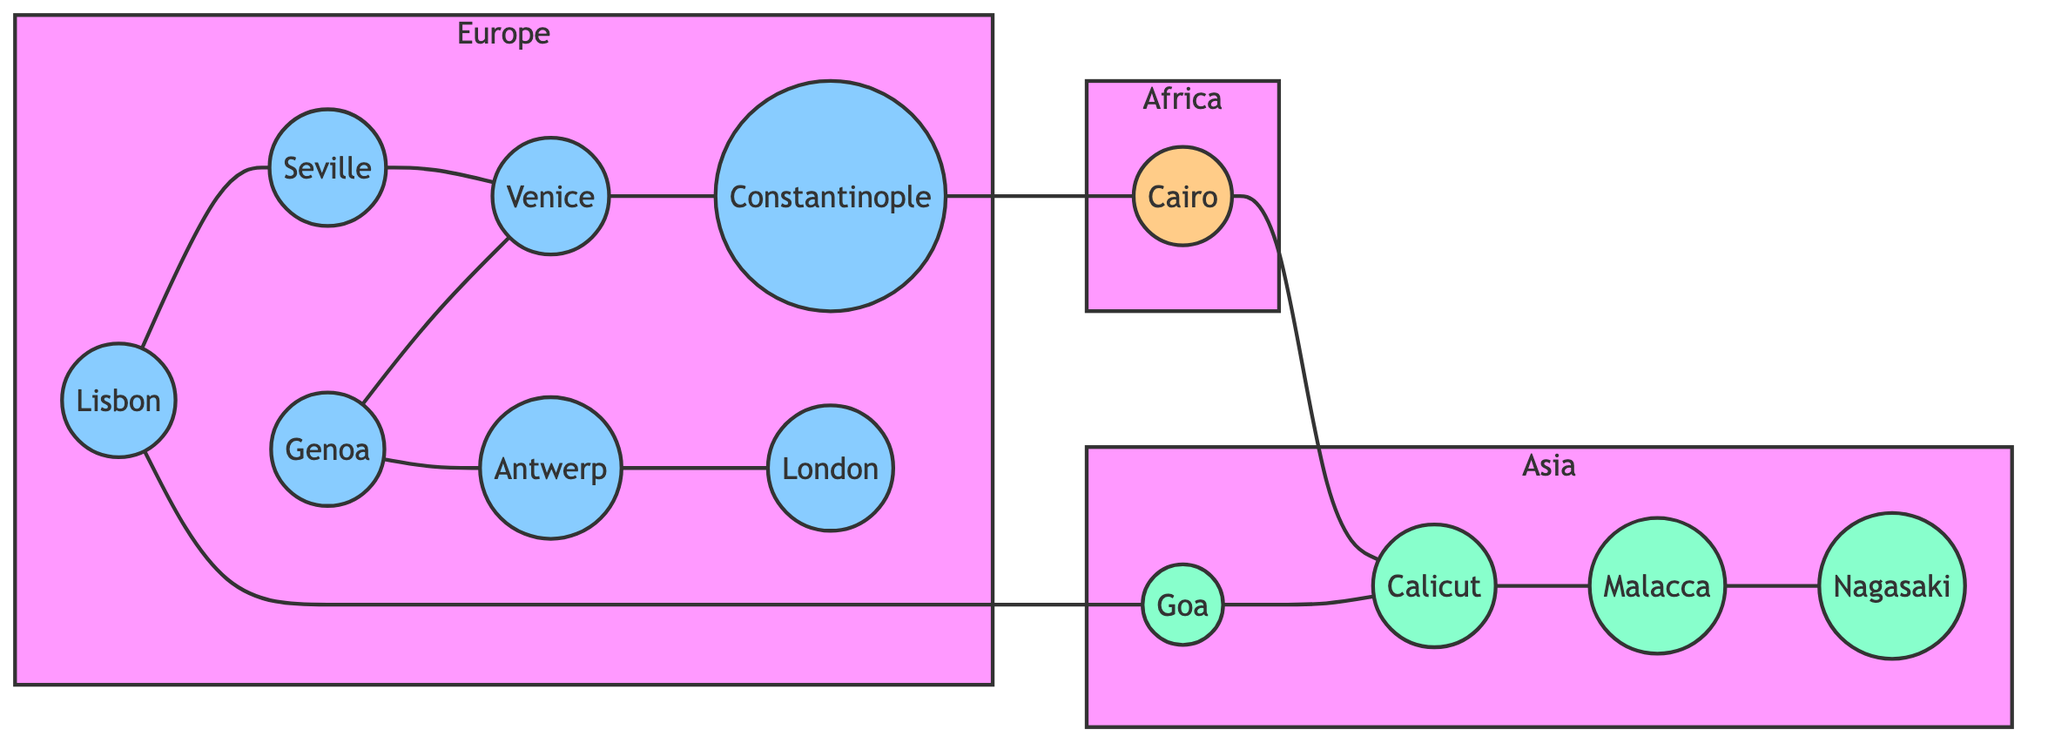What is the total number of nodes in the graph? The graph has nodes representing various trade hubs in the 16th century. Counting each individual node listed in the data gives us a total of 12 nodes.
Answer: 12 Which two cities are directly connected to Lisbon? In the diagram, the edges originating from Lisbon connect it to Seville and Goa. By observing the edges connected to Lisbon, we can identify these two cities.
Answer: Seville, Goa What is the only African city in the graph? The graph depicts various trade hubs from different continents. By examining the nodes, we find that Cairo is the only city placed in the Africa subgraph.
Answer: Cairo Which European city is connected to Antwerp? The connections in the graph show that Antwerp is directly connected to London. By looking at the edge linking these two nodes, we can identify London as the connected city.
Answer: London How many direct connections does Venice have? Reviewing the edges connected to Venice shows that it has two direct connections: one to Seville and another to Constantinople. Thus, the total number of direct connections can be determined as two.
Answer: 2 Which city is the last in the trade route starting from Malacca? Tracing the edges from Malacca leads to Nagasaki, as Malacca has a direct connection to Nagasaki. Therefore, Nagasaki is the endpoint of this trade route.
Answer: Nagasaki What is the relationship between Genoa and Venice? According to the edges in the graph, Genoa has a direct connection to Venice, as identified in the connections provided in the edges list. Thus, they are directly linked.
Answer: Directly connected Which two cities connect the trade route from Cairo to Malacca? Starting from Cairo, we see a path leading to Calicut and then to Malacca, through the edges identified. Thus, the cities connecting both should be Calicut and Malacca.
Answer: Calicut, Malacca What is the total number of edges in the graph? Counting all the lines connecting the nodes in the 'edges' section provides the total number of direct links or edges in the graph. There are 11 edges in total.
Answer: 11 